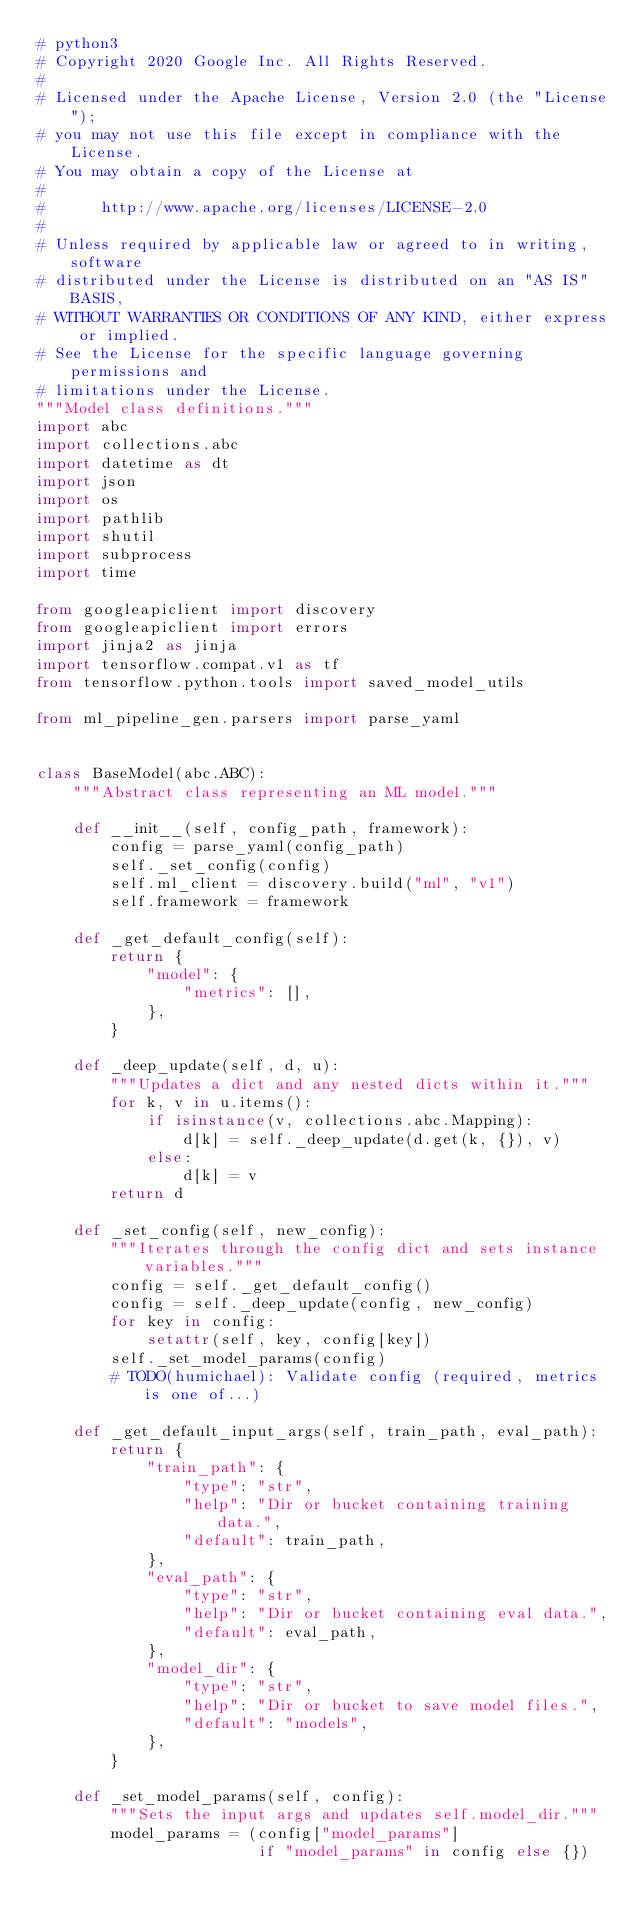Convert code to text. <code><loc_0><loc_0><loc_500><loc_500><_Python_># python3
# Copyright 2020 Google Inc. All Rights Reserved.
#
# Licensed under the Apache License, Version 2.0 (the "License");
# you may not use this file except in compliance with the License.
# You may obtain a copy of the License at
#
#      http://www.apache.org/licenses/LICENSE-2.0
#
# Unless required by applicable law or agreed to in writing, software
# distributed under the License is distributed on an "AS IS" BASIS,
# WITHOUT WARRANTIES OR CONDITIONS OF ANY KIND, either express or implied.
# See the License for the specific language governing permissions and
# limitations under the License.
"""Model class definitions."""
import abc
import collections.abc
import datetime as dt
import json
import os
import pathlib
import shutil
import subprocess
import time

from googleapiclient import discovery
from googleapiclient import errors
import jinja2 as jinja
import tensorflow.compat.v1 as tf
from tensorflow.python.tools import saved_model_utils

from ml_pipeline_gen.parsers import parse_yaml


class BaseModel(abc.ABC):
    """Abstract class representing an ML model."""

    def __init__(self, config_path, framework):
        config = parse_yaml(config_path)
        self._set_config(config)
        self.ml_client = discovery.build("ml", "v1")
        self.framework = framework

    def _get_default_config(self):
        return {
            "model": {
                "metrics": [],
            },
        }

    def _deep_update(self, d, u):
        """Updates a dict and any nested dicts within it."""
        for k, v in u.items():
            if isinstance(v, collections.abc.Mapping):
                d[k] = self._deep_update(d.get(k, {}), v)
            else:
                d[k] = v
        return d

    def _set_config(self, new_config):
        """Iterates through the config dict and sets instance variables."""
        config = self._get_default_config()
        config = self._deep_update(config, new_config)
        for key in config:
            setattr(self, key, config[key])
        self._set_model_params(config)
        # TODO(humichael): Validate config (required, metrics is one of...)

    def _get_default_input_args(self, train_path, eval_path):
        return {
            "train_path": {
                "type": "str",
                "help": "Dir or bucket containing training data.",
                "default": train_path,
            },
            "eval_path": {
                "type": "str",
                "help": "Dir or bucket containing eval data.",
                "default": eval_path,
            },
            "model_dir": {
                "type": "str",
                "help": "Dir or bucket to save model files.",
                "default": "models",
            },
        }

    def _set_model_params(self, config):
        """Sets the input args and updates self.model_dir."""
        model_params = (config["model_params"]
                        if "model_params" in config else {})</code> 